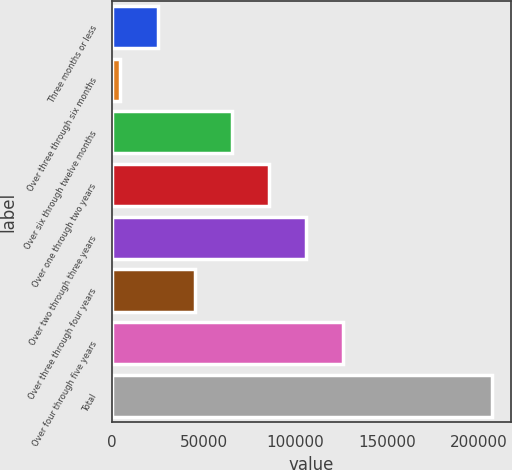Convert chart to OTSL. <chart><loc_0><loc_0><loc_500><loc_500><bar_chart><fcel>Three months or less<fcel>Over three through six months<fcel>Over six through twelve months<fcel>Over one through two years<fcel>Over two through three years<fcel>Over three through four years<fcel>Over four through five years<fcel>Total<nl><fcel>24904.8<fcel>4692<fcel>65330.4<fcel>85543.2<fcel>105756<fcel>45117.6<fcel>125969<fcel>206820<nl></chart> 